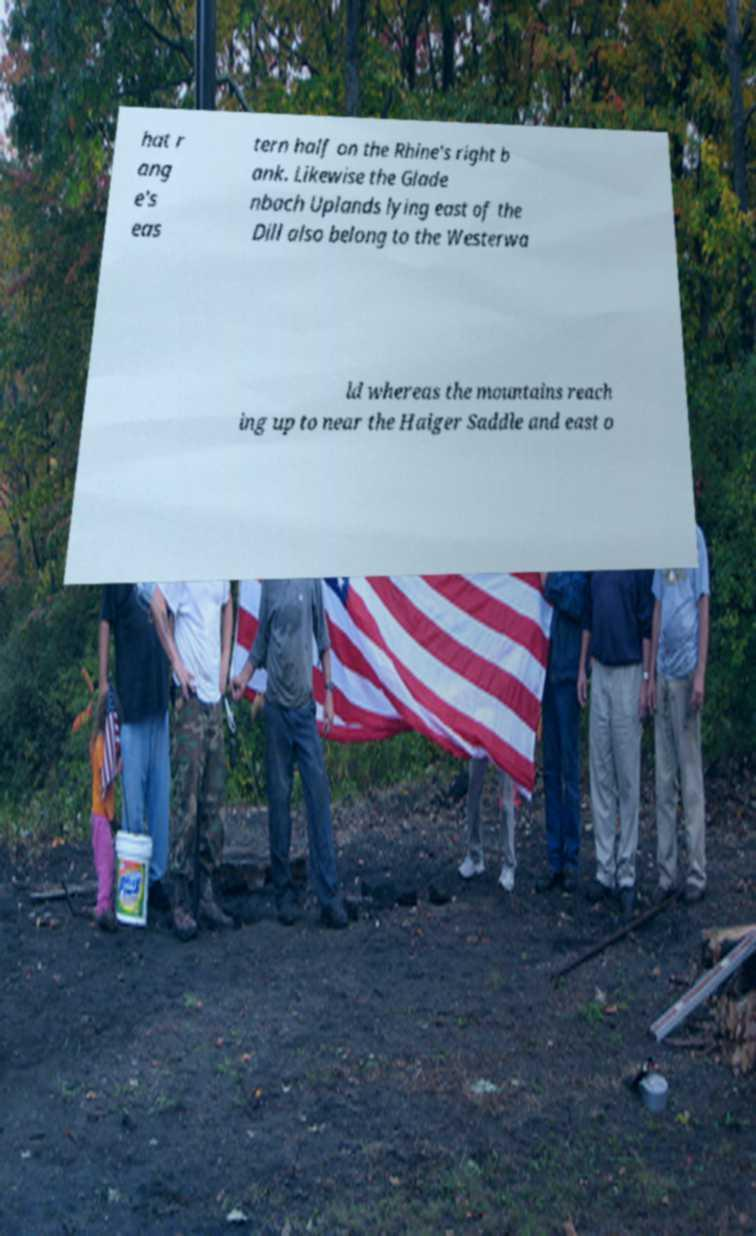Please identify and transcribe the text found in this image. hat r ang e's eas tern half on the Rhine's right b ank. Likewise the Glade nbach Uplands lying east of the Dill also belong to the Westerwa ld whereas the mountains reach ing up to near the Haiger Saddle and east o 